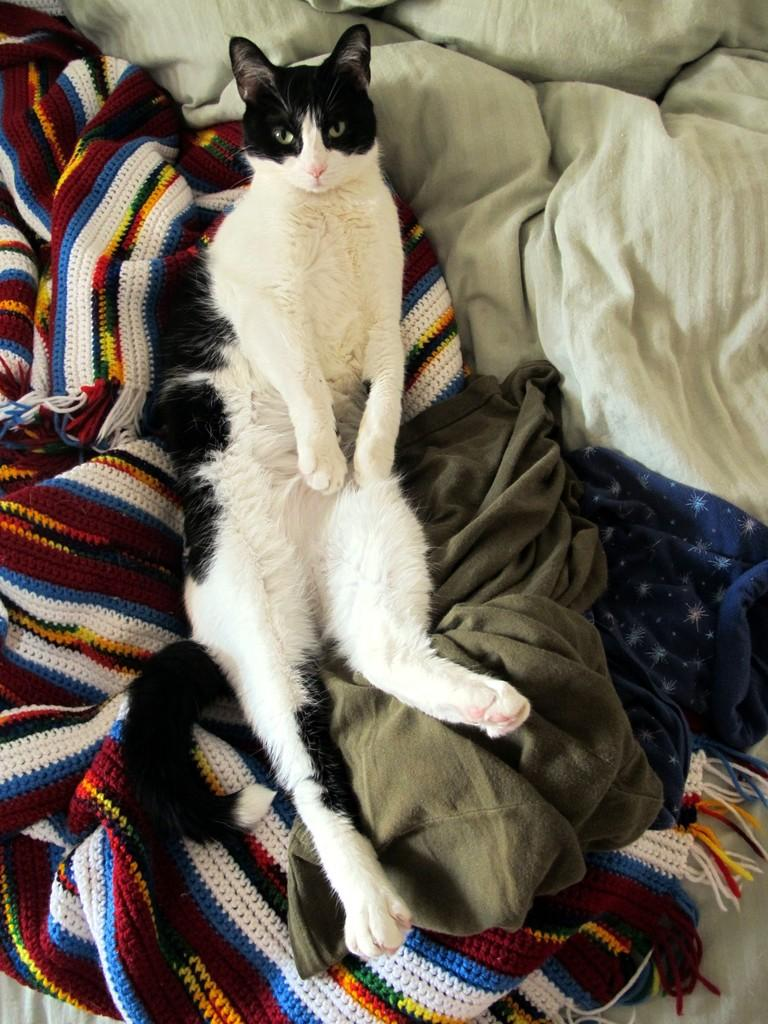What is the main subject of the image? The main subject of the image is many clothes. Is there anything else present in the image besides the clothes? Yes, a cat is laying on the clothes. What is the cat doing in the image? The cat is laying on the clothes and looking at the picture. What type of advice can be heard from the cat in the image? There is no indication in the image that the cat is giving any advice. What type of vegetable is present in the image? There is no vegetable present in the image. 